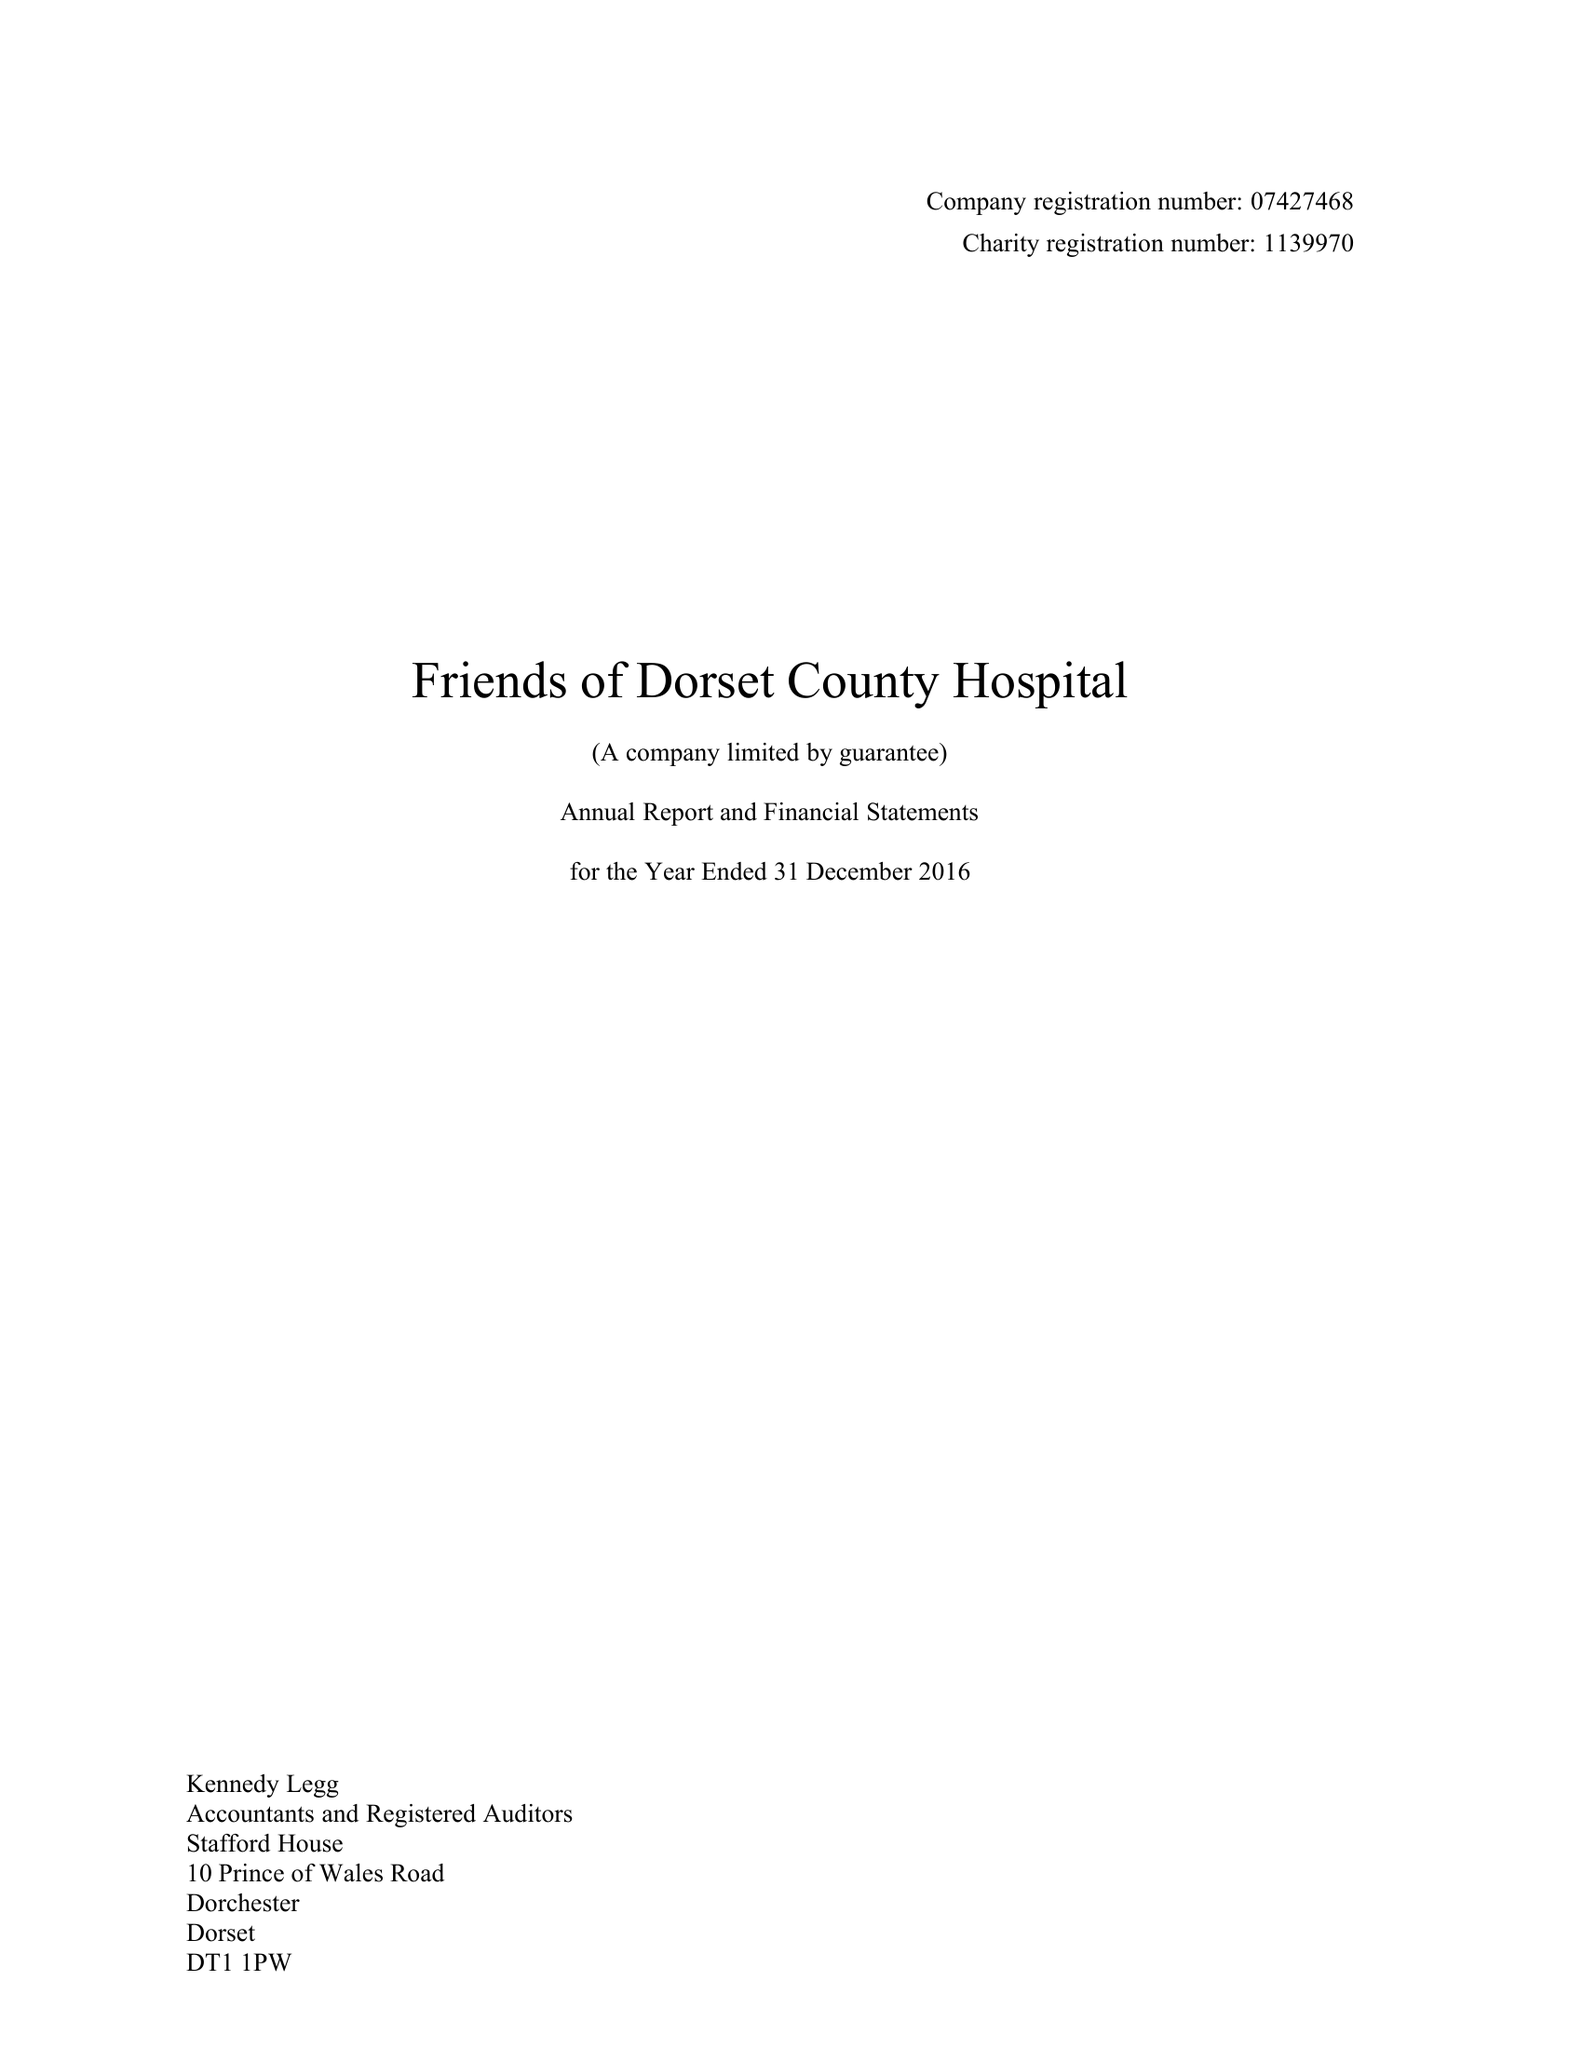What is the value for the income_annually_in_british_pounds?
Answer the question using a single word or phrase. 146351.00 